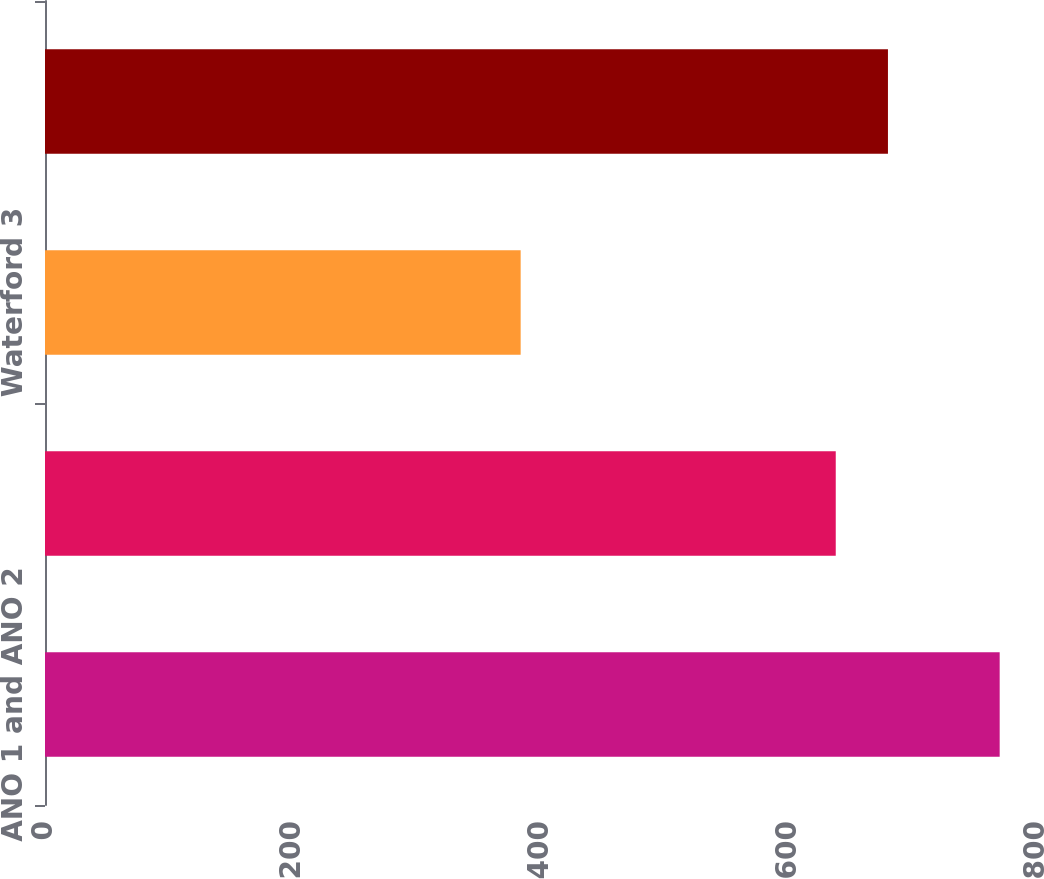<chart> <loc_0><loc_0><loc_500><loc_500><bar_chart><fcel>ANO 1 and ANO 2<fcel>River Bend<fcel>Waterford 3<fcel>Grand Gulf<nl><fcel>769.9<fcel>637.7<fcel>383.6<fcel>679.8<nl></chart> 